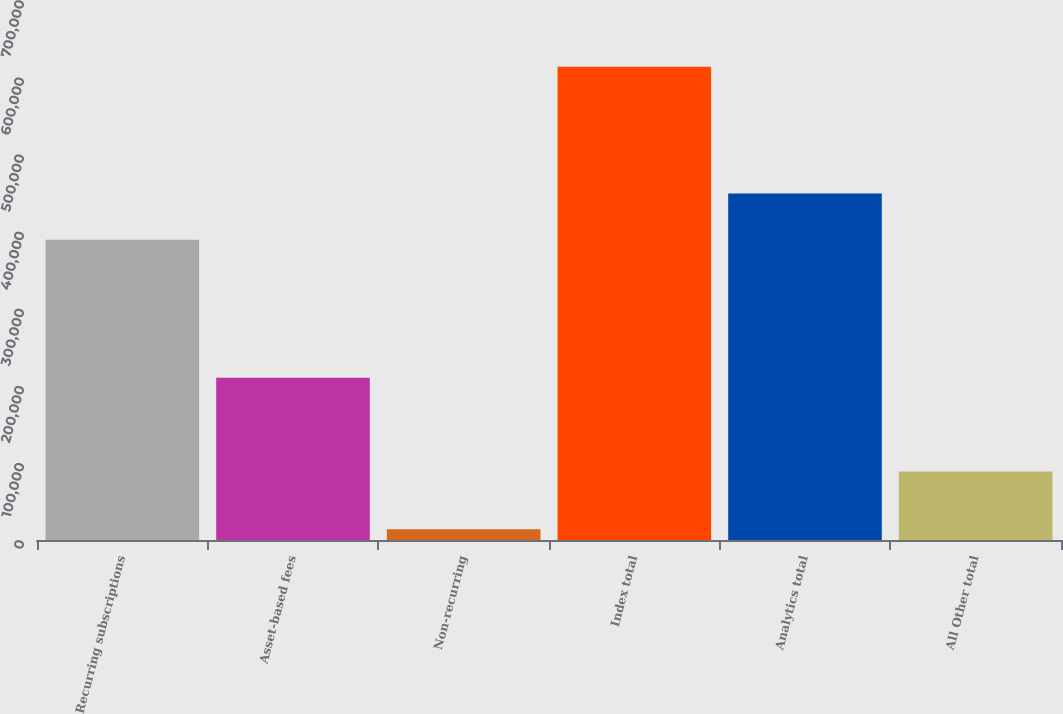<chart> <loc_0><loc_0><loc_500><loc_500><bar_chart><fcel>Recurring subscriptions<fcel>Asset-based fees<fcel>Non-recurring<fcel>Index total<fcel>Analytics total<fcel>All Other total<nl><fcel>389348<fcel>210229<fcel>13974<fcel>613551<fcel>449306<fcel>88765<nl></chart> 